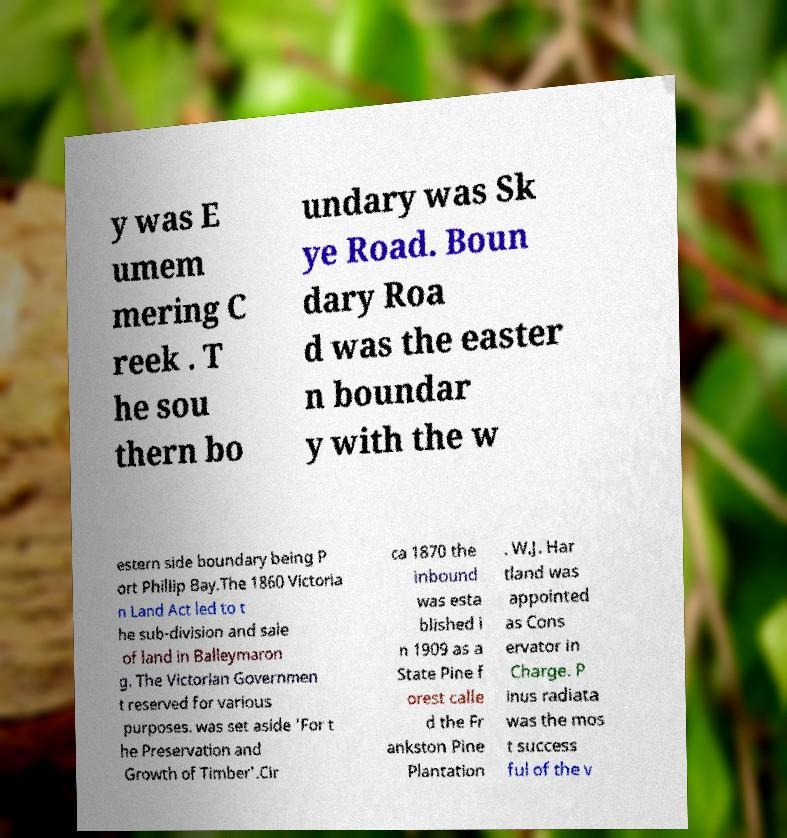I need the written content from this picture converted into text. Can you do that? y was E umem mering C reek . T he sou thern bo undary was Sk ye Road. Boun dary Roa d was the easter n boundar y with the w estern side boundary being P ort Phillip Bay.The 1860 Victoria n Land Act led to t he sub-division and sale of land in Balleymaron g. The Victorian Governmen t reserved for various purposes. was set aside 'For t he Preservation and Growth of Timber'.Cir ca 1870 the inbound was esta blished i n 1909 as a State Pine f orest calle d the Fr ankston Pine Plantation . W.J. Har tland was appointed as Cons ervator in Charge. P inus radiata was the mos t success ful of the v 